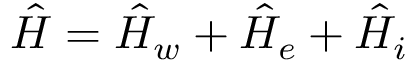<formula> <loc_0><loc_0><loc_500><loc_500>\hat { H } = \hat { H } _ { w } + \hat { H } _ { e } + \hat { H } _ { i }</formula> 